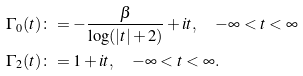<formula> <loc_0><loc_0><loc_500><loc_500>\Gamma _ { 0 } ( t ) & \colon = - \frac { \beta } { \log ( | t | + 2 ) } + i t , \quad - \infty < t < \infty \\ \Gamma _ { 2 } ( t ) & \colon = 1 + i t , \quad - \infty < t < \infty .</formula> 